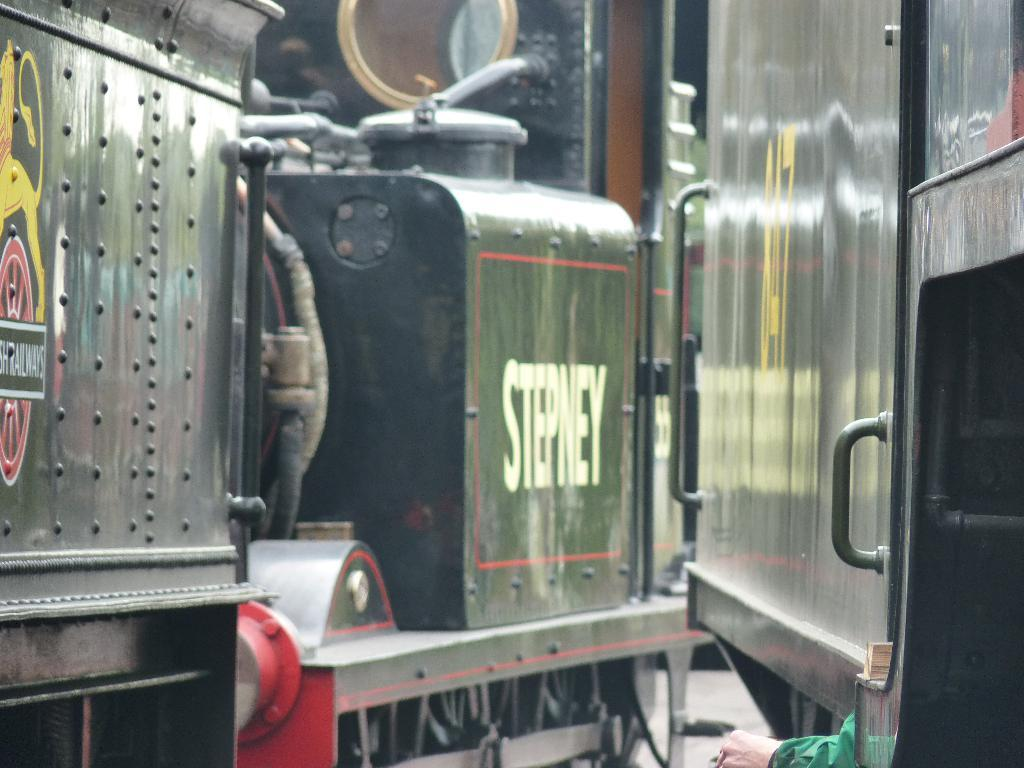What type of vehicles can be seen in the image? There are trains in the image. What else can be seen in the image besides the trains? There is text visible in the image, and there is an image on the train. Can you describe the person's hand in the image? A person's hand is present in the image, but no further details about the hand are provided. What type of holiday is being celebrated in the image? There is no indication of a holiday being celebrated in the image. Can you describe the boot that is present in the image? There is no boot present in the image. 